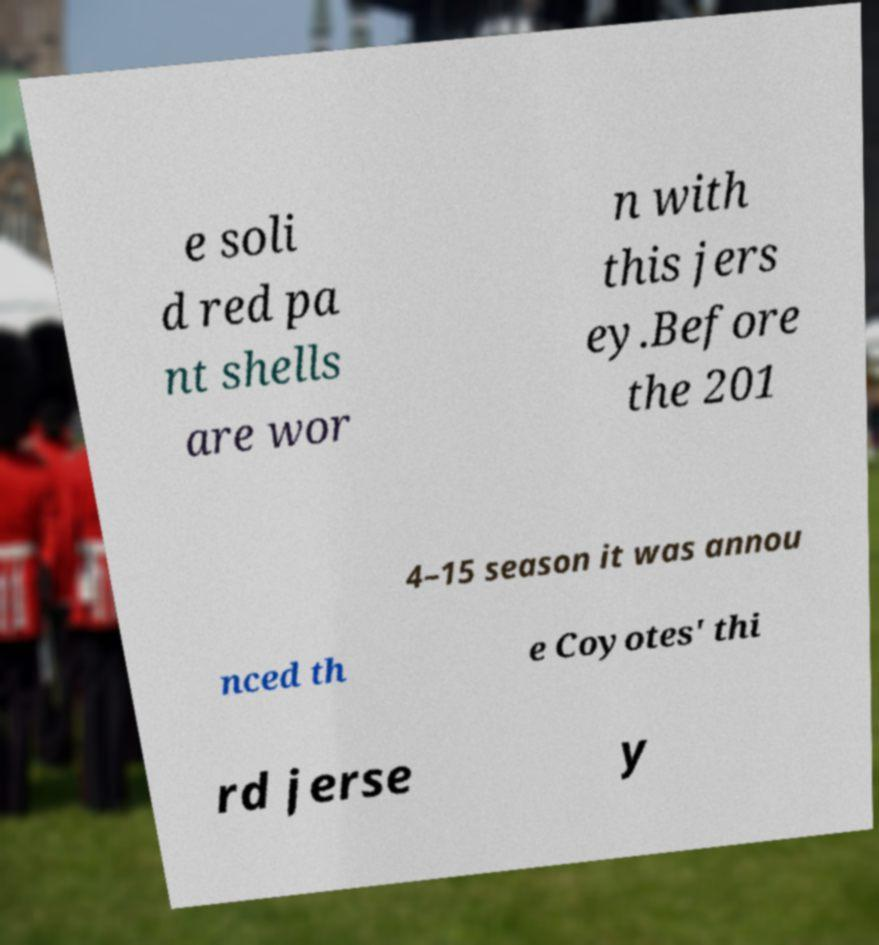Please identify and transcribe the text found in this image. e soli d red pa nt shells are wor n with this jers ey.Before the 201 4–15 season it was annou nced th e Coyotes' thi rd jerse y 